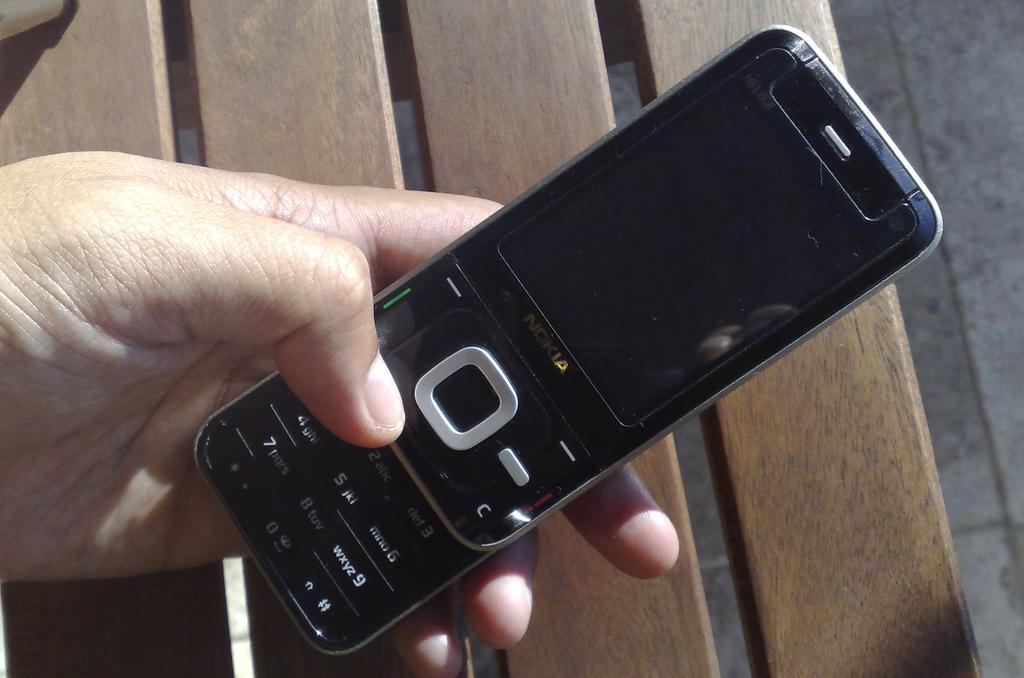Is this a nokia?
Make the answer very short. Yes. 